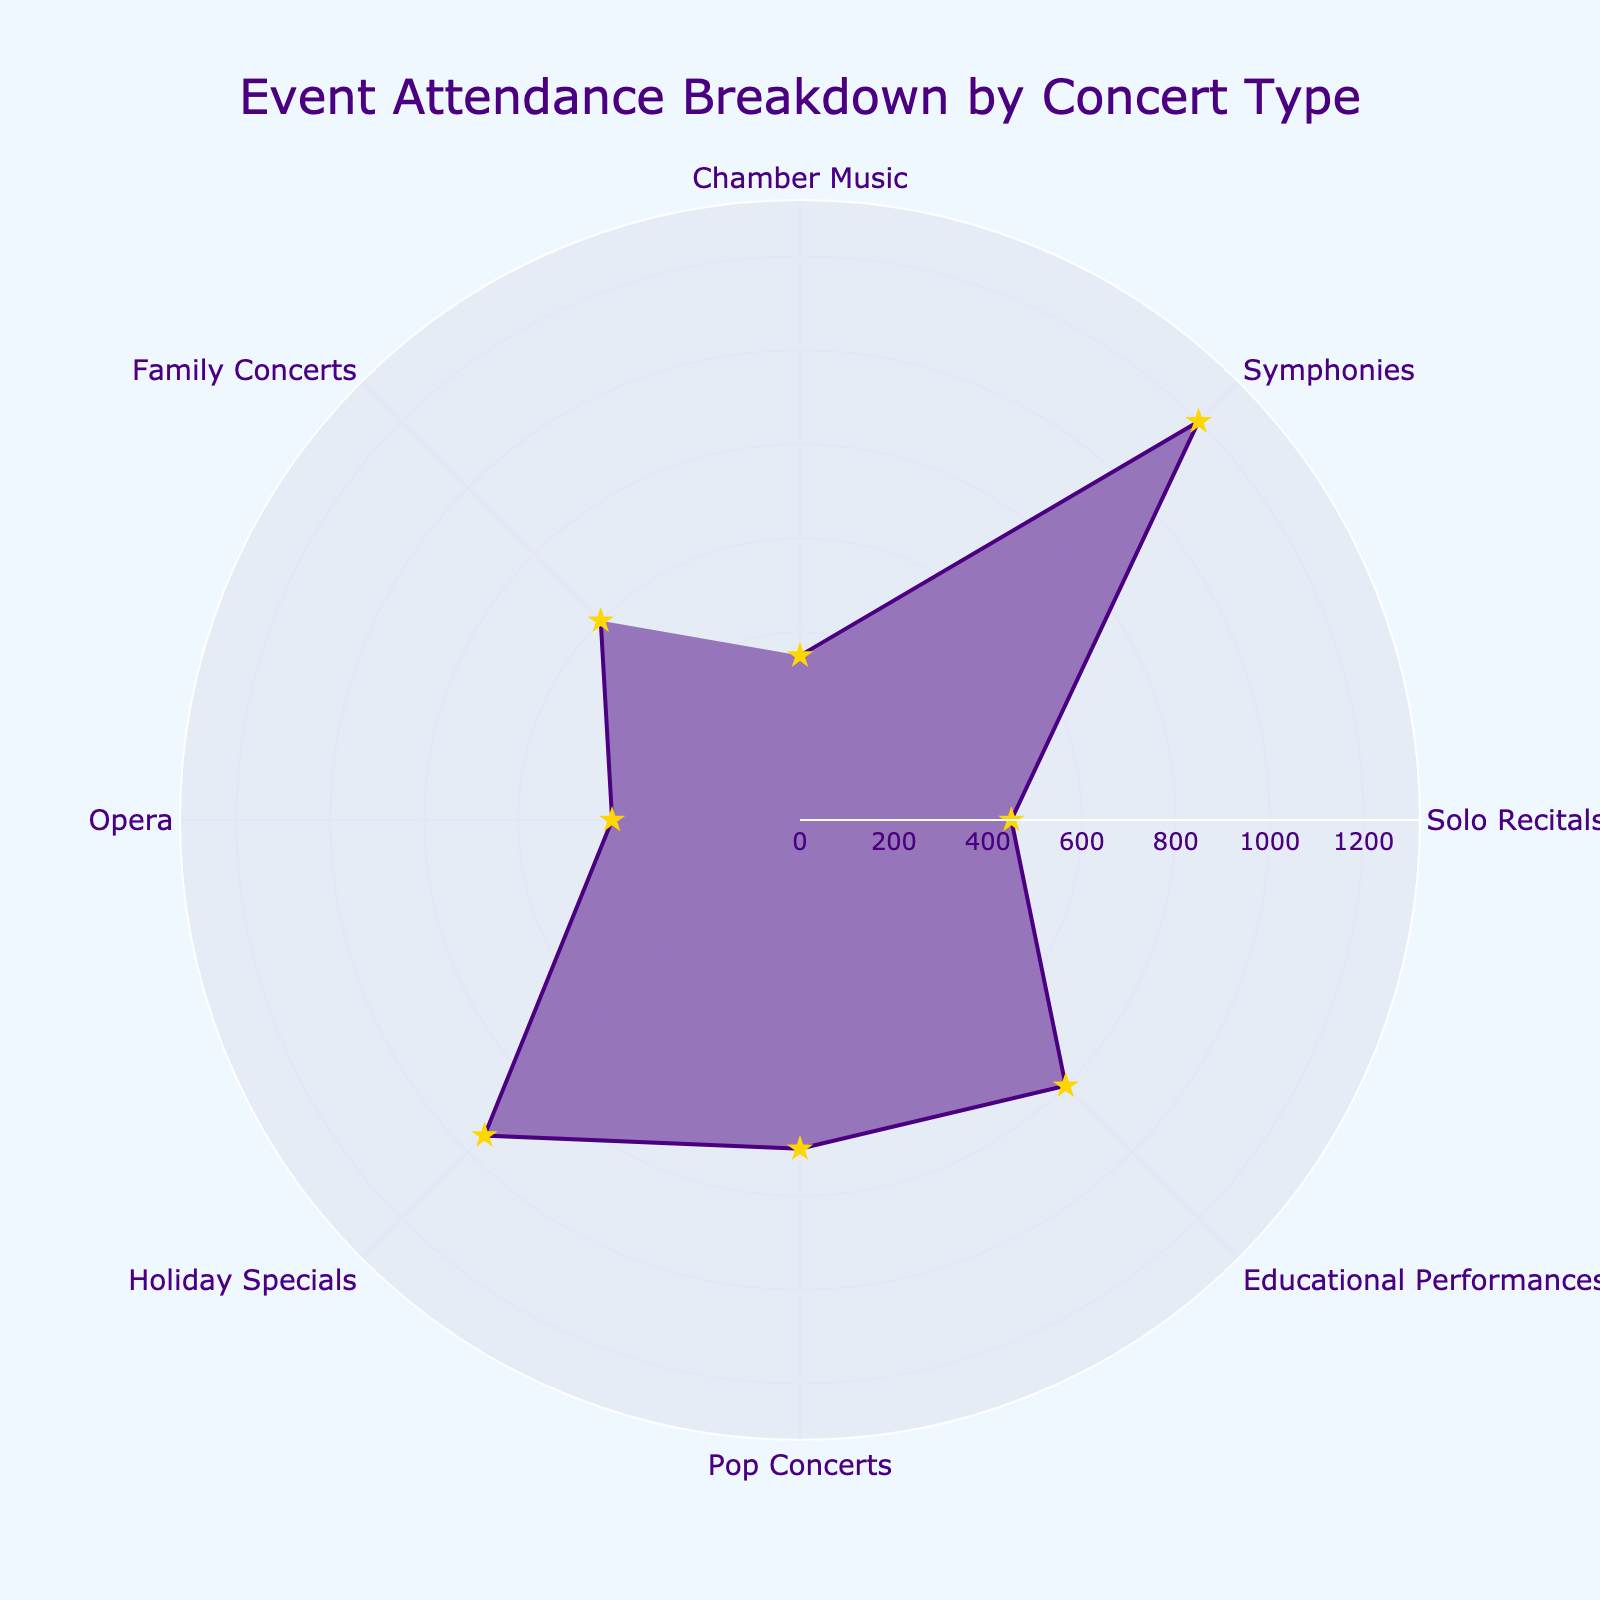How many concert types are represented in the figure? To answer this question, count the distinct concert type labels shown around the circumference of the polar chart. There should be eight different segments, each representing a unique concert type.
Answer: 8 Which concert type had the highest attendance? Look for the segment with the longest radial distance from the center of the polar chart. The segment labeled "Symphonies" extends the furthest, indicating the highest attendance.
Answer: Symphonies What is the title of the figure? The title should be clearly visible at the top of the polar chart. It reads "Event Attendance Breakdown by Concert Type."
Answer: Event Attendance Breakdown by Concert Type What is the combined attendance of Solo Recitals and Opera? To find this, locate the segments for Solo Recitals and Opera, note their attendance values, and add them. Solo Recitals have 450 attendees, and Opera has 400 attendees. The sum is 450 + 400 = 850.
Answer: 850 Which has a higher attendance: Educational Performances or Holiday Specials? Compare the radial distances for Educational Performances and Holiday Specials. The segments show Educational Performances at 800 attendees and Holiday Specials at 950 attendees. Holiday Specials have a higher attendance.
Answer: Holiday Specials Which concert type has a radial distance of 600 attendees? Find the segment where the radial distance reaches 600 and identify the corresponding concert type. "Family Concerts" has a radial distance of 600.
Answer: Family Concerts How much greater is the attendance for Symphonies compared to Chamber Music? Determine the attendance values for Symphonies (1200) and Chamber Music (350). Subtract the smaller value from the larger: 1200 - 350 = 850.
Answer: 850 What is the average attendance across all concert types? To find the average, sum all the attendance values and divide by the number of concert types (8). (350+1200+450+800+700+950+400+600) / 8 = 5,450 / 8 = 681.25.
Answer: 681.25 Which three concert types have the lowest attendance? Identify the three segments with the shortest radial distances. They represent Chamber Music (350), Opera (400), and Solo Recitals (450).
Answer: Chamber Music, Opera, Solo Recitals 